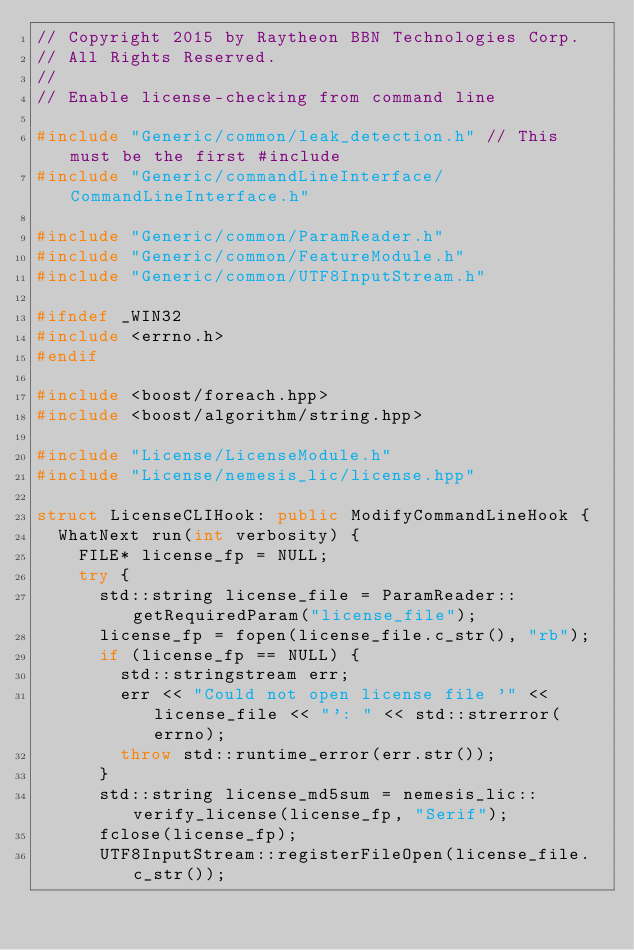<code> <loc_0><loc_0><loc_500><loc_500><_C++_>// Copyright 2015 by Raytheon BBN Technologies Corp.
// All Rights Reserved.
//
// Enable license-checking from command line

#include "Generic/common/leak_detection.h" // This must be the first #include
#include "Generic/commandLineInterface/CommandLineInterface.h"

#include "Generic/common/ParamReader.h"
#include "Generic/common/FeatureModule.h"
#include "Generic/common/UTF8InputStream.h"

#ifndef _WIN32
#include <errno.h>
#endif

#include <boost/foreach.hpp>
#include <boost/algorithm/string.hpp>

#include "License/LicenseModule.h"
#include "License/nemesis_lic/license.hpp"

struct LicenseCLIHook: public ModifyCommandLineHook {
	WhatNext run(int verbosity) {
		FILE* license_fp = NULL;
		try {
			std::string license_file = ParamReader::getRequiredParam("license_file");
			license_fp = fopen(license_file.c_str(), "rb");
			if (license_fp == NULL) {
				std::stringstream err;
				err << "Could not open license file '" << license_file << "': " << std::strerror(errno);
				throw std::runtime_error(err.str());
			}
			std::string license_md5sum = nemesis_lic::verify_license(license_fp, "Serif");
			fclose(license_fp);
			UTF8InputStream::registerFileOpen(license_file.c_str());</code> 